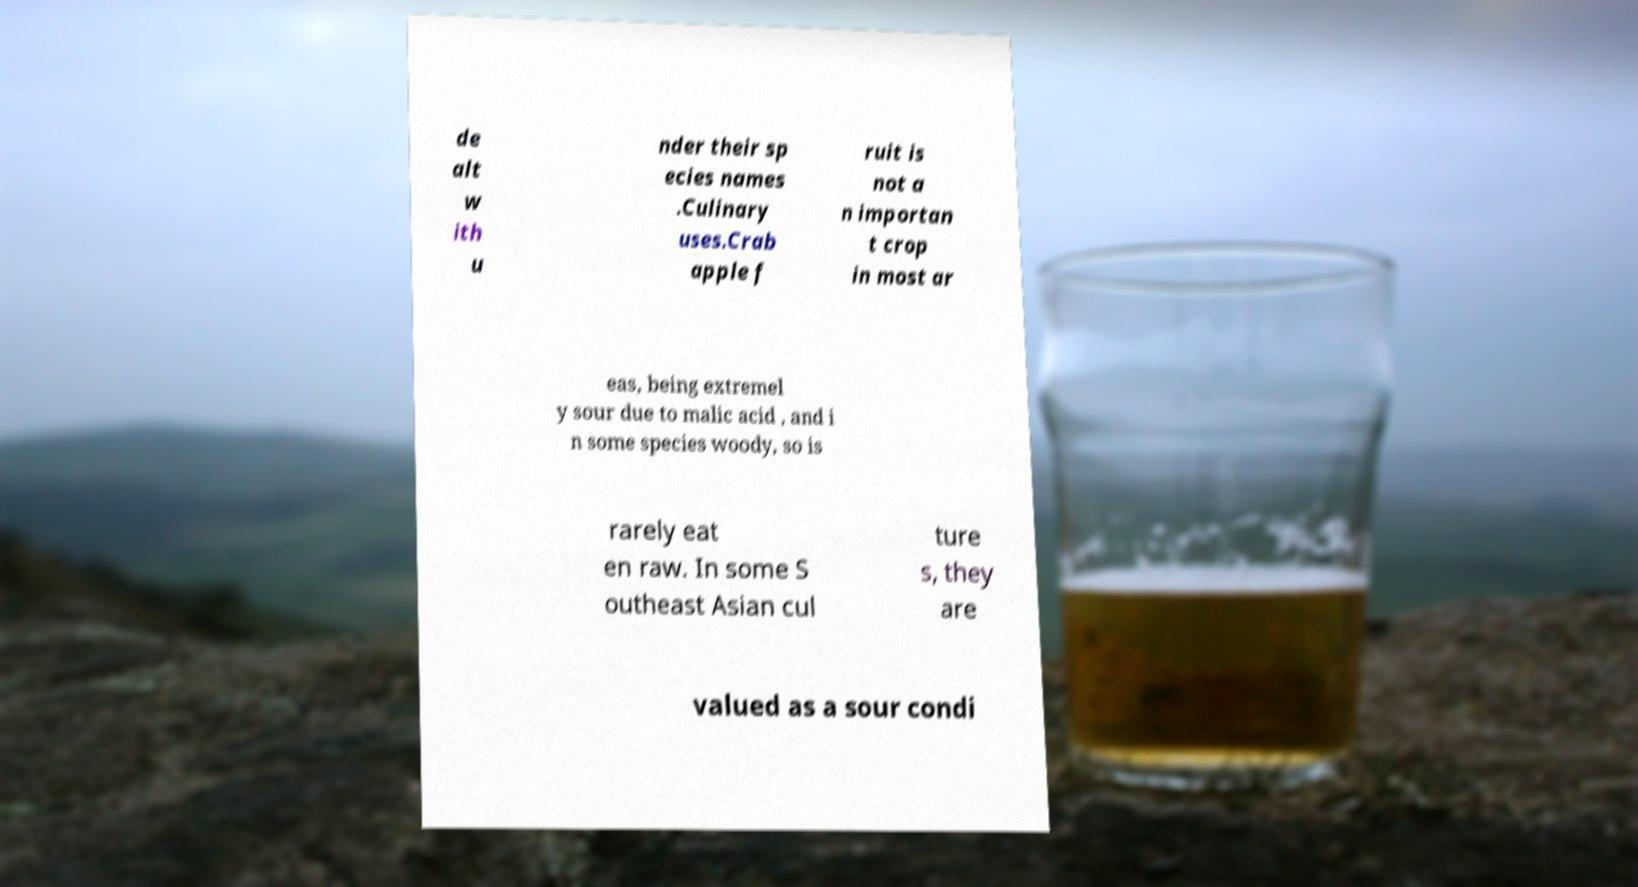Could you assist in decoding the text presented in this image and type it out clearly? de alt w ith u nder their sp ecies names .Culinary uses.Crab apple f ruit is not a n importan t crop in most ar eas, being extremel y sour due to malic acid , and i n some species woody, so is rarely eat en raw. In some S outheast Asian cul ture s, they are valued as a sour condi 